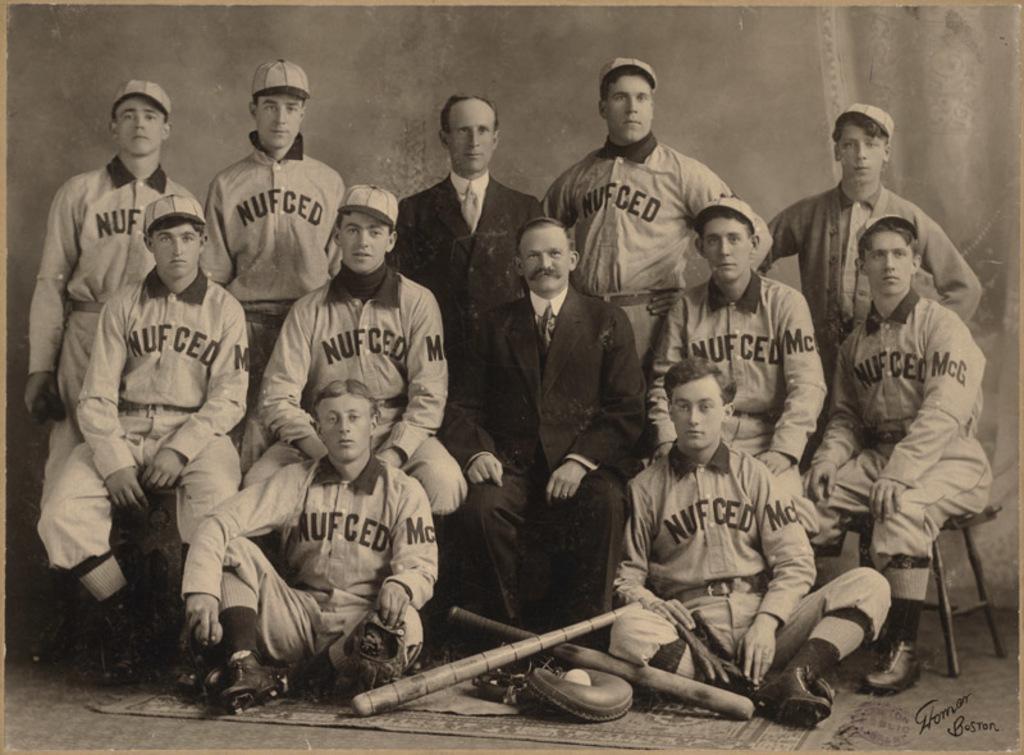What city is listed in the bottom right corner?
Give a very brief answer. Boston. 